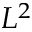Convert formula to latex. <formula><loc_0><loc_0><loc_500><loc_500>L ^ { 2 }</formula> 